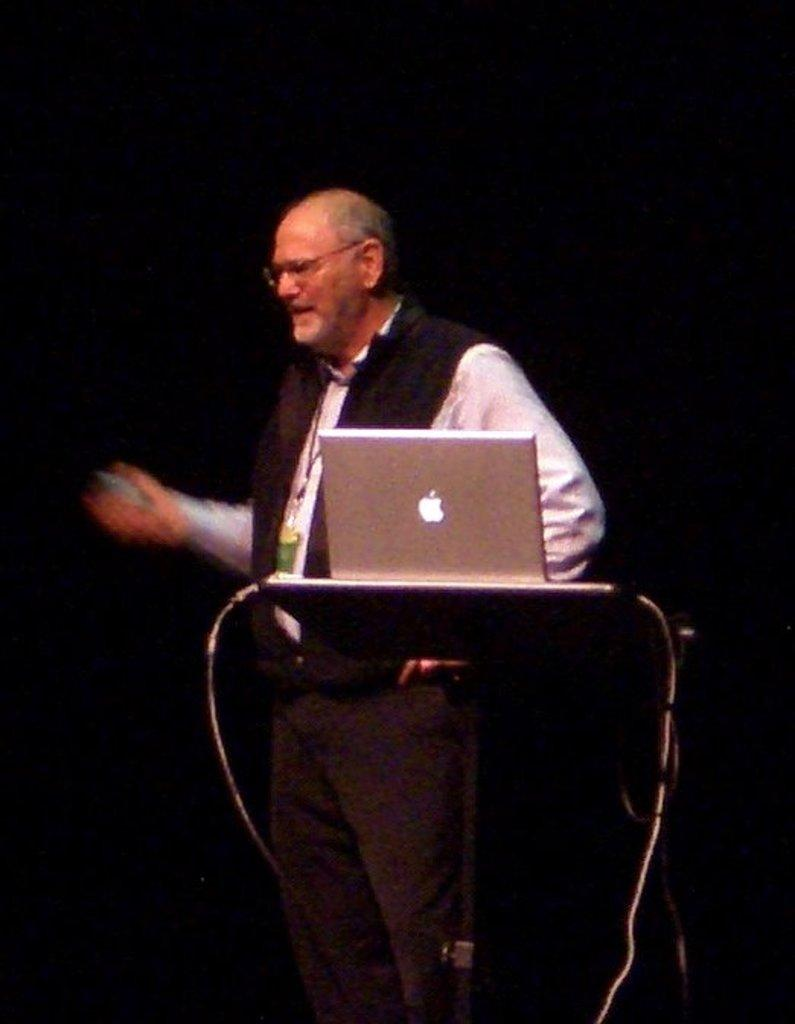Who or what is in the center of the image? There is a person in the center of the image. What object can be seen near the person? There is a podium in the image. What electronic device is visible in the image? There is a laptop in the image. What type of accessory is present in the image? Cables are present in the image. How would you describe the lighting in the image? The background of the image is dark. What is the person in the image doing? The person is talking. How does the person in the image join the light and dark colors together? There is no mention of light and dark colors being joined together in the image. The background is simply described as dark. 